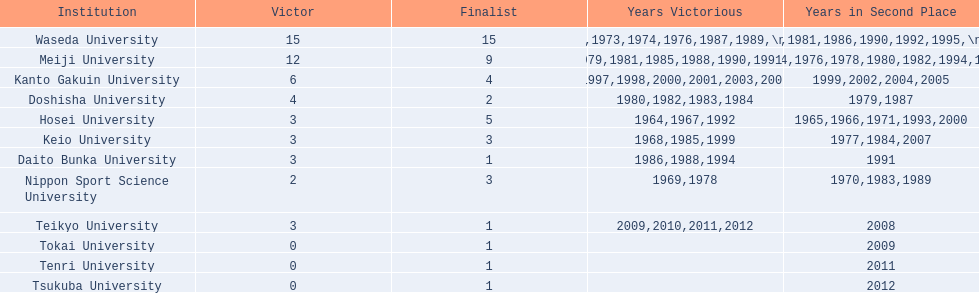Which university had 6 wins? Kanto Gakuin University. Which university had 12 wins? Meiji University. Which university had more than 12 wins? Waseda University. 